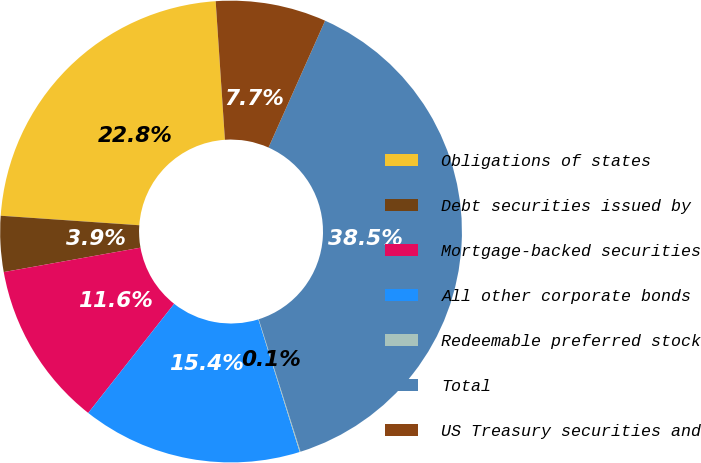Convert chart to OTSL. <chart><loc_0><loc_0><loc_500><loc_500><pie_chart><fcel>Obligations of states<fcel>Debt securities issued by<fcel>Mortgage-backed securities<fcel>All other corporate bonds<fcel>Redeemable preferred stock<fcel>Total<fcel>US Treasury securities and<nl><fcel>22.85%<fcel>3.9%<fcel>11.58%<fcel>15.42%<fcel>0.06%<fcel>38.46%<fcel>7.74%<nl></chart> 